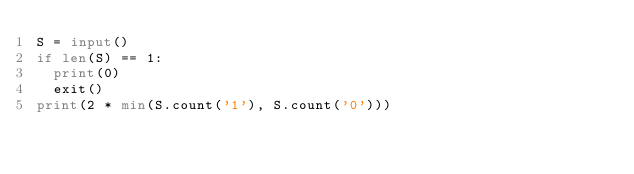Convert code to text. <code><loc_0><loc_0><loc_500><loc_500><_Python_>S = input()
if len(S) == 1:
  print(0)
  exit()
print(2 * min(S.count('1'), S.count('0')))</code> 